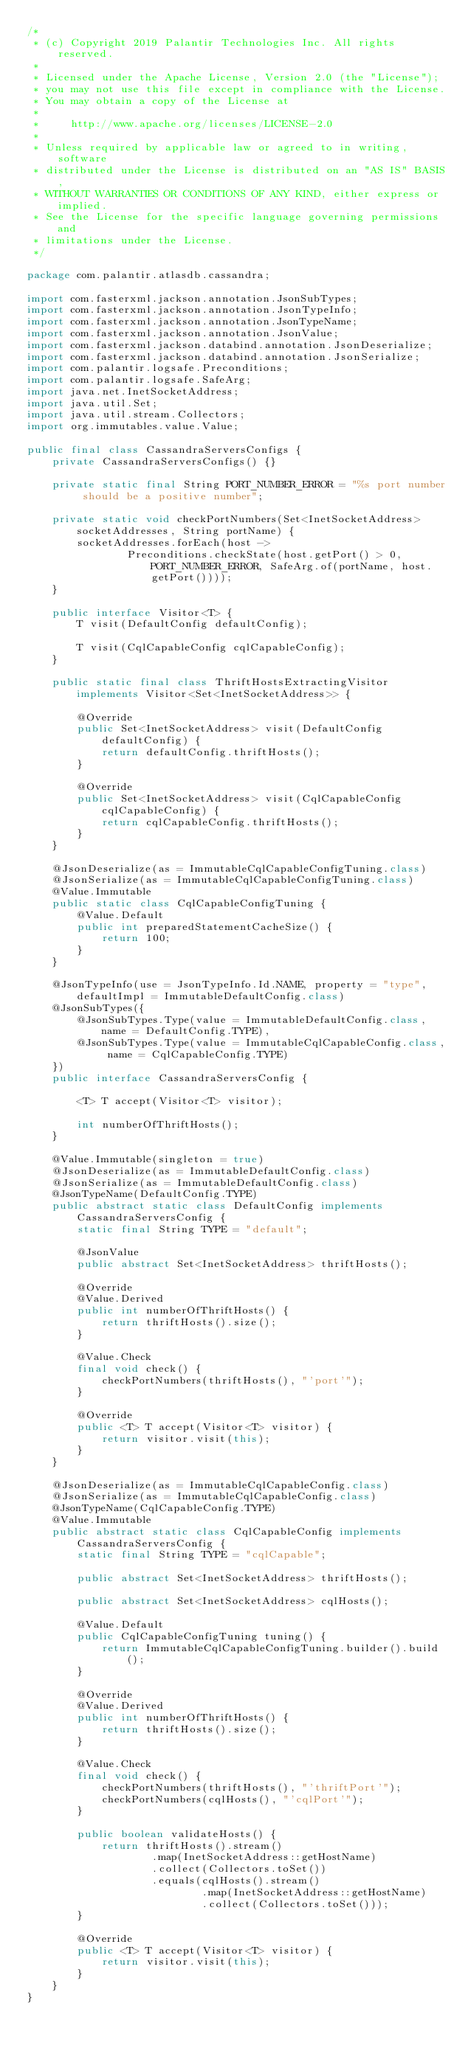<code> <loc_0><loc_0><loc_500><loc_500><_Java_>/*
 * (c) Copyright 2019 Palantir Technologies Inc. All rights reserved.
 *
 * Licensed under the Apache License, Version 2.0 (the "License");
 * you may not use this file except in compliance with the License.
 * You may obtain a copy of the License at
 *
 *     http://www.apache.org/licenses/LICENSE-2.0
 *
 * Unless required by applicable law or agreed to in writing, software
 * distributed under the License is distributed on an "AS IS" BASIS,
 * WITHOUT WARRANTIES OR CONDITIONS OF ANY KIND, either express or implied.
 * See the License for the specific language governing permissions and
 * limitations under the License.
 */

package com.palantir.atlasdb.cassandra;

import com.fasterxml.jackson.annotation.JsonSubTypes;
import com.fasterxml.jackson.annotation.JsonTypeInfo;
import com.fasterxml.jackson.annotation.JsonTypeName;
import com.fasterxml.jackson.annotation.JsonValue;
import com.fasterxml.jackson.databind.annotation.JsonDeserialize;
import com.fasterxml.jackson.databind.annotation.JsonSerialize;
import com.palantir.logsafe.Preconditions;
import com.palantir.logsafe.SafeArg;
import java.net.InetSocketAddress;
import java.util.Set;
import java.util.stream.Collectors;
import org.immutables.value.Value;

public final class CassandraServersConfigs {
    private CassandraServersConfigs() {}

    private static final String PORT_NUMBER_ERROR = "%s port number should be a positive number";

    private static void checkPortNumbers(Set<InetSocketAddress> socketAddresses, String portName) {
        socketAddresses.forEach(host ->
                Preconditions.checkState(host.getPort() > 0, PORT_NUMBER_ERROR, SafeArg.of(portName, host.getPort())));
    }

    public interface Visitor<T> {
        T visit(DefaultConfig defaultConfig);

        T visit(CqlCapableConfig cqlCapableConfig);
    }

    public static final class ThriftHostsExtractingVisitor implements Visitor<Set<InetSocketAddress>> {

        @Override
        public Set<InetSocketAddress> visit(DefaultConfig defaultConfig) {
            return defaultConfig.thriftHosts();
        }

        @Override
        public Set<InetSocketAddress> visit(CqlCapableConfig cqlCapableConfig) {
            return cqlCapableConfig.thriftHosts();
        }
    }

    @JsonDeserialize(as = ImmutableCqlCapableConfigTuning.class)
    @JsonSerialize(as = ImmutableCqlCapableConfigTuning.class)
    @Value.Immutable
    public static class CqlCapableConfigTuning {
        @Value.Default
        public int preparedStatementCacheSize() {
            return 100;
        }
    }

    @JsonTypeInfo(use = JsonTypeInfo.Id.NAME, property = "type", defaultImpl = ImmutableDefaultConfig.class)
    @JsonSubTypes({
        @JsonSubTypes.Type(value = ImmutableDefaultConfig.class, name = DefaultConfig.TYPE),
        @JsonSubTypes.Type(value = ImmutableCqlCapableConfig.class, name = CqlCapableConfig.TYPE)
    })
    public interface CassandraServersConfig {

        <T> T accept(Visitor<T> visitor);

        int numberOfThriftHosts();
    }

    @Value.Immutable(singleton = true)
    @JsonDeserialize(as = ImmutableDefaultConfig.class)
    @JsonSerialize(as = ImmutableDefaultConfig.class)
    @JsonTypeName(DefaultConfig.TYPE)
    public abstract static class DefaultConfig implements CassandraServersConfig {
        static final String TYPE = "default";

        @JsonValue
        public abstract Set<InetSocketAddress> thriftHosts();

        @Override
        @Value.Derived
        public int numberOfThriftHosts() {
            return thriftHosts().size();
        }

        @Value.Check
        final void check() {
            checkPortNumbers(thriftHosts(), "'port'");
        }

        @Override
        public <T> T accept(Visitor<T> visitor) {
            return visitor.visit(this);
        }
    }

    @JsonDeserialize(as = ImmutableCqlCapableConfig.class)
    @JsonSerialize(as = ImmutableCqlCapableConfig.class)
    @JsonTypeName(CqlCapableConfig.TYPE)
    @Value.Immutable
    public abstract static class CqlCapableConfig implements CassandraServersConfig {
        static final String TYPE = "cqlCapable";

        public abstract Set<InetSocketAddress> thriftHosts();

        public abstract Set<InetSocketAddress> cqlHosts();

        @Value.Default
        public CqlCapableConfigTuning tuning() {
            return ImmutableCqlCapableConfigTuning.builder().build();
        }

        @Override
        @Value.Derived
        public int numberOfThriftHosts() {
            return thriftHosts().size();
        }

        @Value.Check
        final void check() {
            checkPortNumbers(thriftHosts(), "'thriftPort'");
            checkPortNumbers(cqlHosts(), "'cqlPort'");
        }

        public boolean validateHosts() {
            return thriftHosts().stream()
                    .map(InetSocketAddress::getHostName)
                    .collect(Collectors.toSet())
                    .equals(cqlHosts().stream()
                            .map(InetSocketAddress::getHostName)
                            .collect(Collectors.toSet()));
        }

        @Override
        public <T> T accept(Visitor<T> visitor) {
            return visitor.visit(this);
        }
    }
}
</code> 